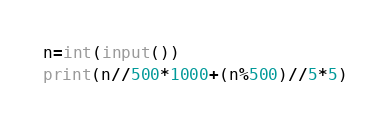<code> <loc_0><loc_0><loc_500><loc_500><_Python_>n=int(input())
print(n//500*1000+(n%500)//5*5)</code> 